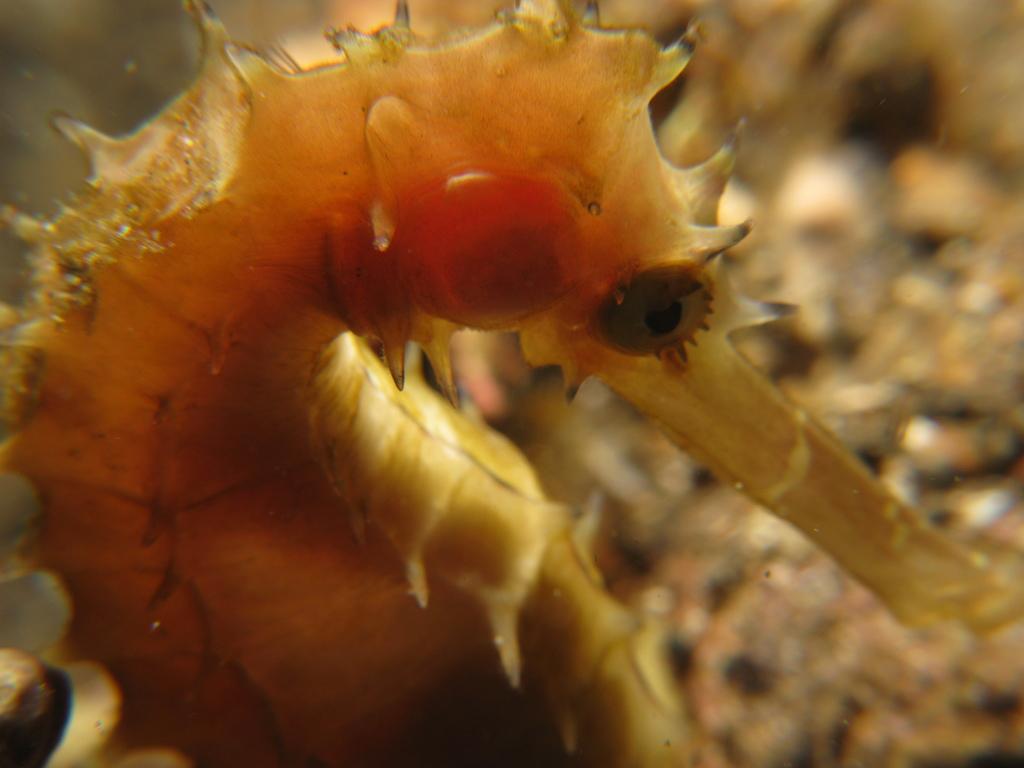Could you give a brief overview of what you see in this image? In this image there is an insect. 